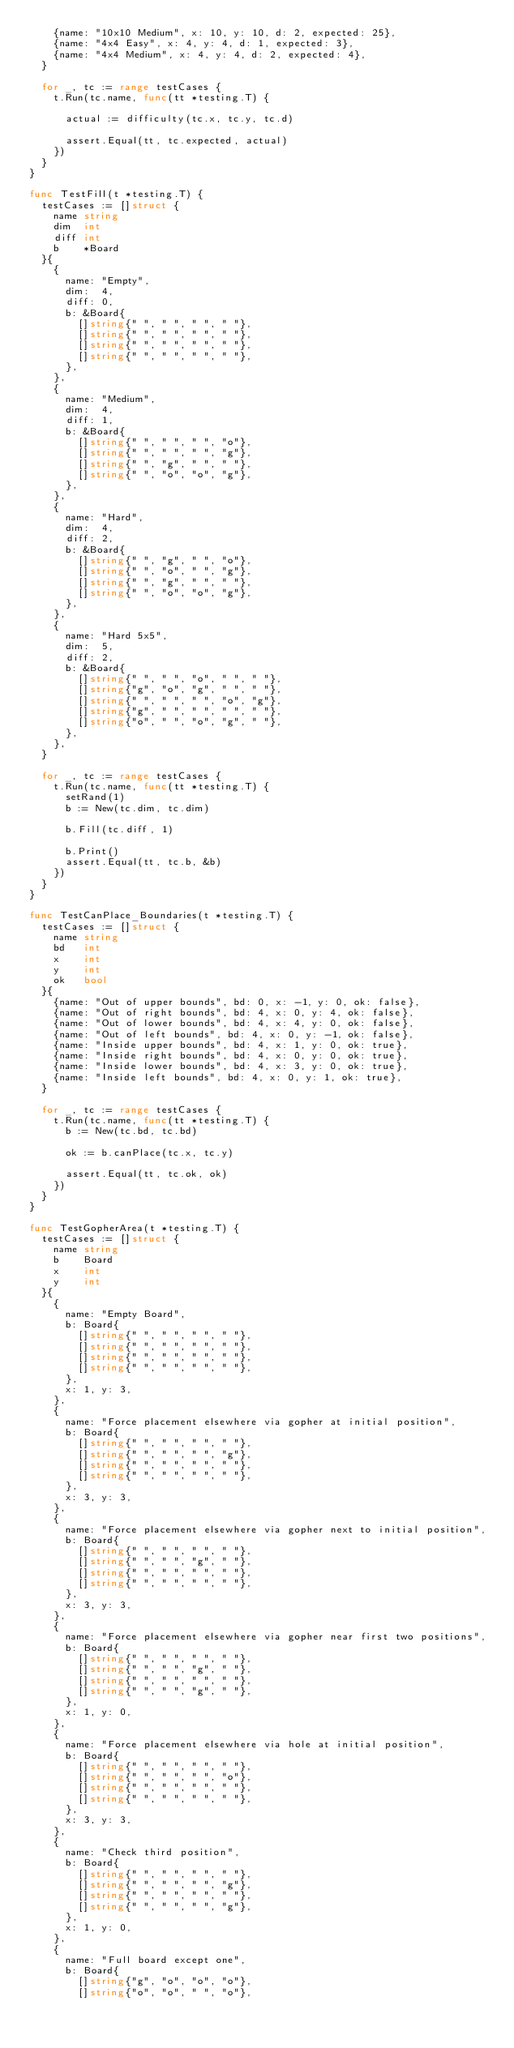Convert code to text. <code><loc_0><loc_0><loc_500><loc_500><_Go_>		{name: "10x10 Medium", x: 10, y: 10, d: 2, expected: 25},
		{name: "4x4 Easy", x: 4, y: 4, d: 1, expected: 3},
		{name: "4x4 Medium", x: 4, y: 4, d: 2, expected: 4},
	}

	for _, tc := range testCases {
		t.Run(tc.name, func(tt *testing.T) {

			actual := difficulty(tc.x, tc.y, tc.d)

			assert.Equal(tt, tc.expected, actual)
		})
	}
}

func TestFill(t *testing.T) {
	testCases := []struct {
		name string
		dim  int
		diff int
		b    *Board
	}{
		{
			name: "Empty",
			dim:  4,
			diff: 0,
			b: &Board{
				[]string{" ", " ", " ", " "},
				[]string{" ", " ", " ", " "},
				[]string{" ", " ", " ", " "},
				[]string{" ", " ", " ", " "},
			},
		},
		{
			name: "Medium",
			dim:  4,
			diff: 1,
			b: &Board{
				[]string{" ", " ", " ", "o"},
				[]string{" ", " ", " ", "g"},
				[]string{" ", "g", " ", " "},
				[]string{" ", "o", "o", "g"},
			},
		},
		{
			name: "Hard",
			dim:  4,
			diff: 2,
			b: &Board{
				[]string{" ", "g", " ", "o"},
				[]string{" ", "o", " ", "g"},
				[]string{" ", "g", " ", " "},
				[]string{" ", "o", "o", "g"},
			},
		},
		{
			name: "Hard 5x5",
			dim:  5,
			diff: 2,
			b: &Board{
				[]string{" ", " ", "o", " ", " "},
				[]string{"g", "o", "g", " ", " "},
				[]string{" ", " ", " ", "o", "g"},
				[]string{"g", " ", " ", " ", " "},
				[]string{"o", " ", "o", "g", " "},
			},
		},
	}

	for _, tc := range testCases {
		t.Run(tc.name, func(tt *testing.T) {
			setRand(1)
			b := New(tc.dim, tc.dim)

			b.Fill(tc.diff, 1)

			b.Print()
			assert.Equal(tt, tc.b, &b)
		})
	}
}

func TestCanPlace_Boundaries(t *testing.T) {
	testCases := []struct {
		name string
		bd   int
		x    int
		y    int
		ok   bool
	}{
		{name: "Out of upper bounds", bd: 0, x: -1, y: 0, ok: false},
		{name: "Out of right bounds", bd: 4, x: 0, y: 4, ok: false},
		{name: "Out of lower bounds", bd: 4, x: 4, y: 0, ok: false},
		{name: "Out of left bounds", bd: 4, x: 0, y: -1, ok: false},
		{name: "Inside upper bounds", bd: 4, x: 1, y: 0, ok: true},
		{name: "Inside right bounds", bd: 4, x: 0, y: 0, ok: true},
		{name: "Inside lower bounds", bd: 4, x: 3, y: 0, ok: true},
		{name: "Inside left bounds", bd: 4, x: 0, y: 1, ok: true},
	}

	for _, tc := range testCases {
		t.Run(tc.name, func(tt *testing.T) {
			b := New(tc.bd, tc.bd)

			ok := b.canPlace(tc.x, tc.y)

			assert.Equal(tt, tc.ok, ok)
		})
	}
}

func TestGopherArea(t *testing.T) {
	testCases := []struct {
		name string
		b    Board
		x    int
		y    int
	}{
		{
			name: "Empty Board",
			b: Board{
				[]string{" ", " ", " ", " "},
				[]string{" ", " ", " ", " "},
				[]string{" ", " ", " ", " "},
				[]string{" ", " ", " ", " "},
			},
			x: 1, y: 3,
		},
		{
			name: "Force placement elsewhere via gopher at initial position",
			b: Board{
				[]string{" ", " ", " ", " "},
				[]string{" ", " ", " ", "g"},
				[]string{" ", " ", " ", " "},
				[]string{" ", " ", " ", " "},
			},
			x: 3, y: 3,
		},
		{
			name: "Force placement elsewhere via gopher next to initial position",
			b: Board{
				[]string{" ", " ", " ", " "},
				[]string{" ", " ", "g", " "},
				[]string{" ", " ", " ", " "},
				[]string{" ", " ", " ", " "},
			},
			x: 3, y: 3,
		},
		{
			name: "Force placement elsewhere via gopher near first two positions",
			b: Board{
				[]string{" ", " ", " ", " "},
				[]string{" ", " ", "g", " "},
				[]string{" ", " ", " ", " "},
				[]string{" ", " ", "g", " "},
			},
			x: 1, y: 0,
		},
		{
			name: "Force placement elsewhere via hole at initial position",
			b: Board{
				[]string{" ", " ", " ", " "},
				[]string{" ", " ", " ", "o"},
				[]string{" ", " ", " ", " "},
				[]string{" ", " ", " ", " "},
			},
			x: 3, y: 3,
		},
		{
			name: "Check third position",
			b: Board{
				[]string{" ", " ", " ", " "},
				[]string{" ", " ", " ", "g"},
				[]string{" ", " ", " ", " "},
				[]string{" ", " ", " ", "g"},
			},
			x: 1, y: 0,
		},
		{
			name: "Full board except one",
			b: Board{
				[]string{"g", "o", "o", "o"},
				[]string{"o", "o", " ", "o"},</code> 